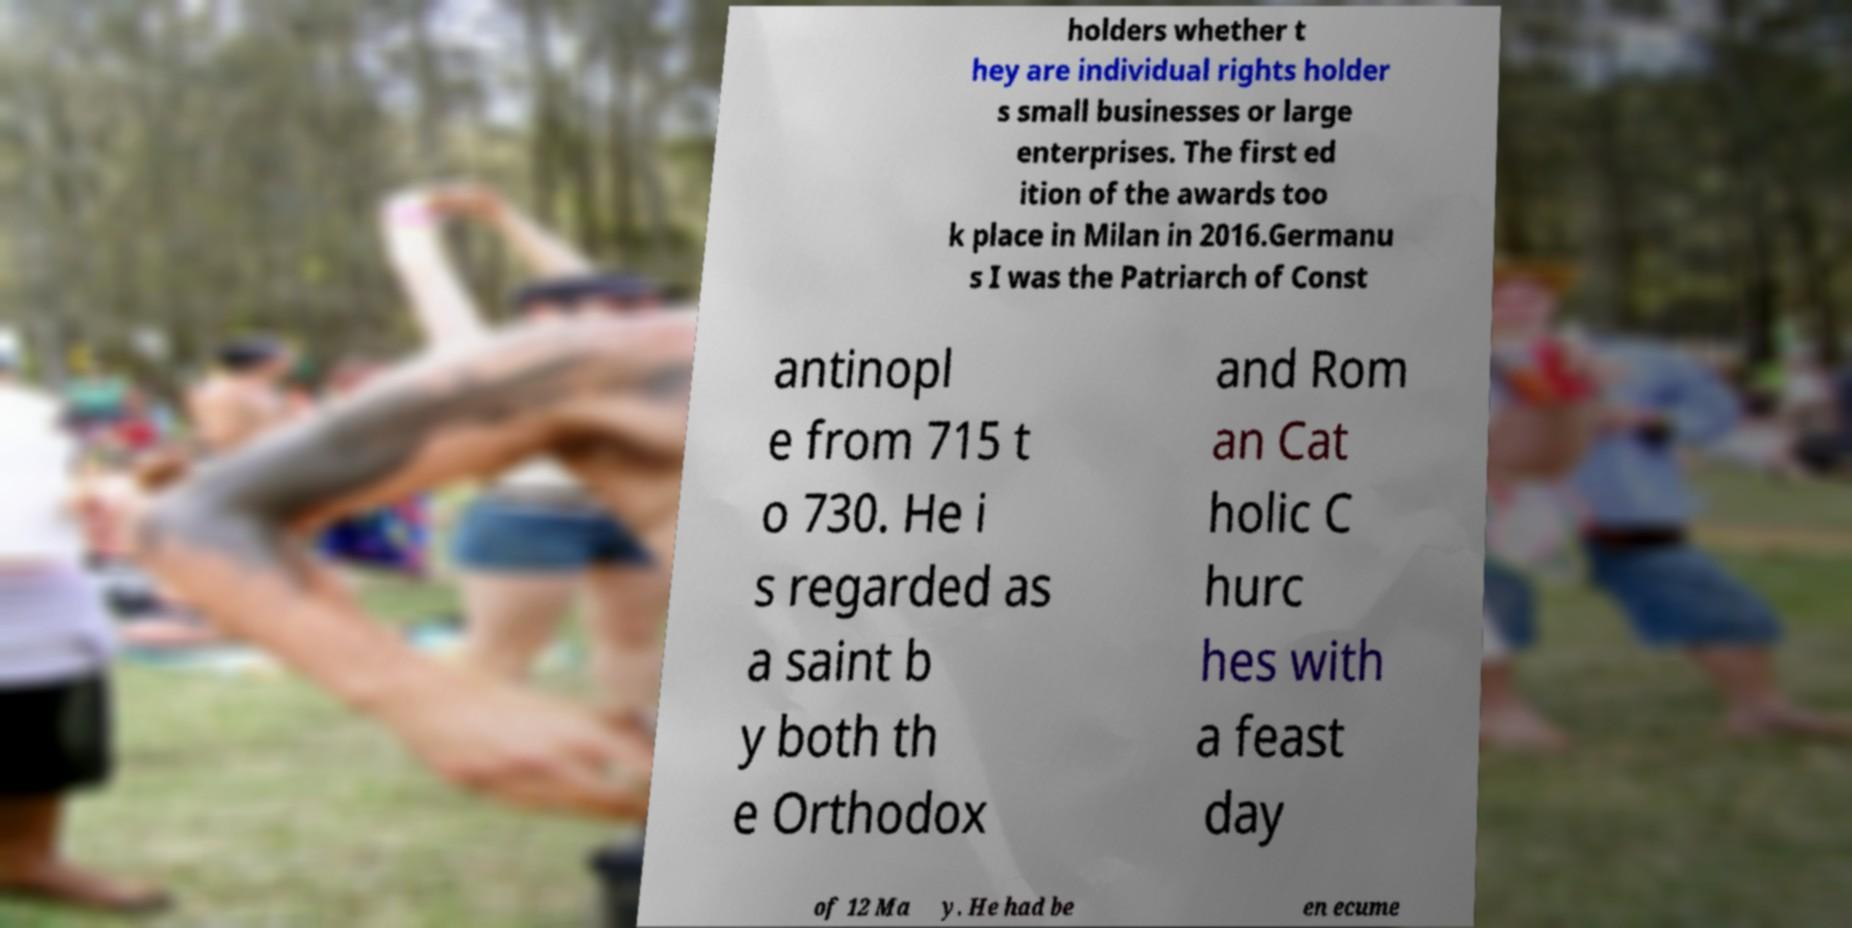There's text embedded in this image that I need extracted. Can you transcribe it verbatim? holders whether t hey are individual rights holder s small businesses or large enterprises. The first ed ition of the awards too k place in Milan in 2016.Germanu s I was the Patriarch of Const antinopl e from 715 t o 730. He i s regarded as a saint b y both th e Orthodox and Rom an Cat holic C hurc hes with a feast day of 12 Ma y. He had be en ecume 